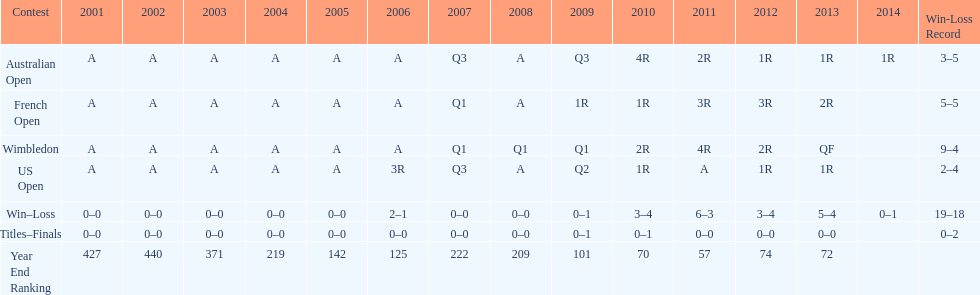In what year was the best year end ranking achieved? 2011. 